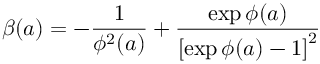<formula> <loc_0><loc_0><loc_500><loc_500>\beta ( a ) = - \frac { 1 } { \phi ^ { 2 } ( a ) } + \frac { \exp { \phi ( a ) } } { \left [ \exp { \phi ( a ) } - 1 \right ] ^ { 2 } }</formula> 